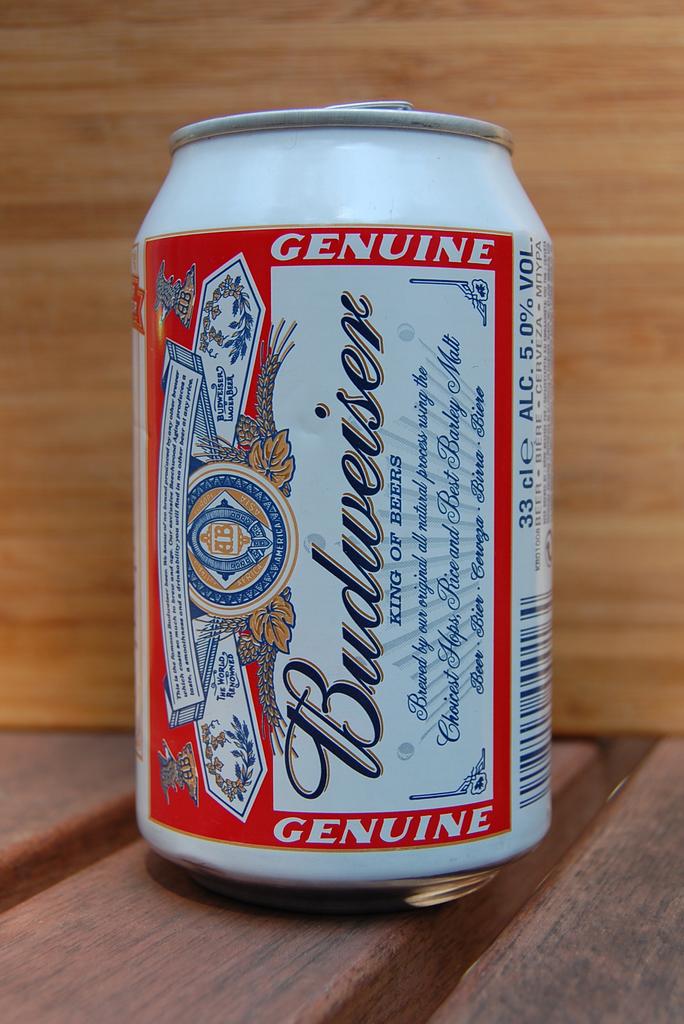What word is at the top?
Provide a short and direct response. Genuine. 